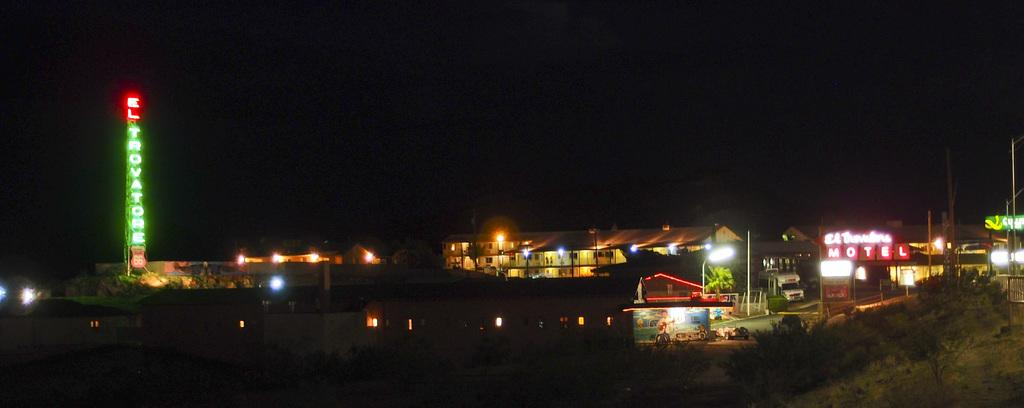What type of structures can be seen in the image? There are buildings and shops in the image. What other elements are present in the image besides structures? There are plants and a tower in the image. Can you describe the right side of the image? A fence is present on the right side of the image. What type of metal is the tiger made of in the image? There is no tiger present in the image, so it is not possible to determine the type of metal it might be made of. 